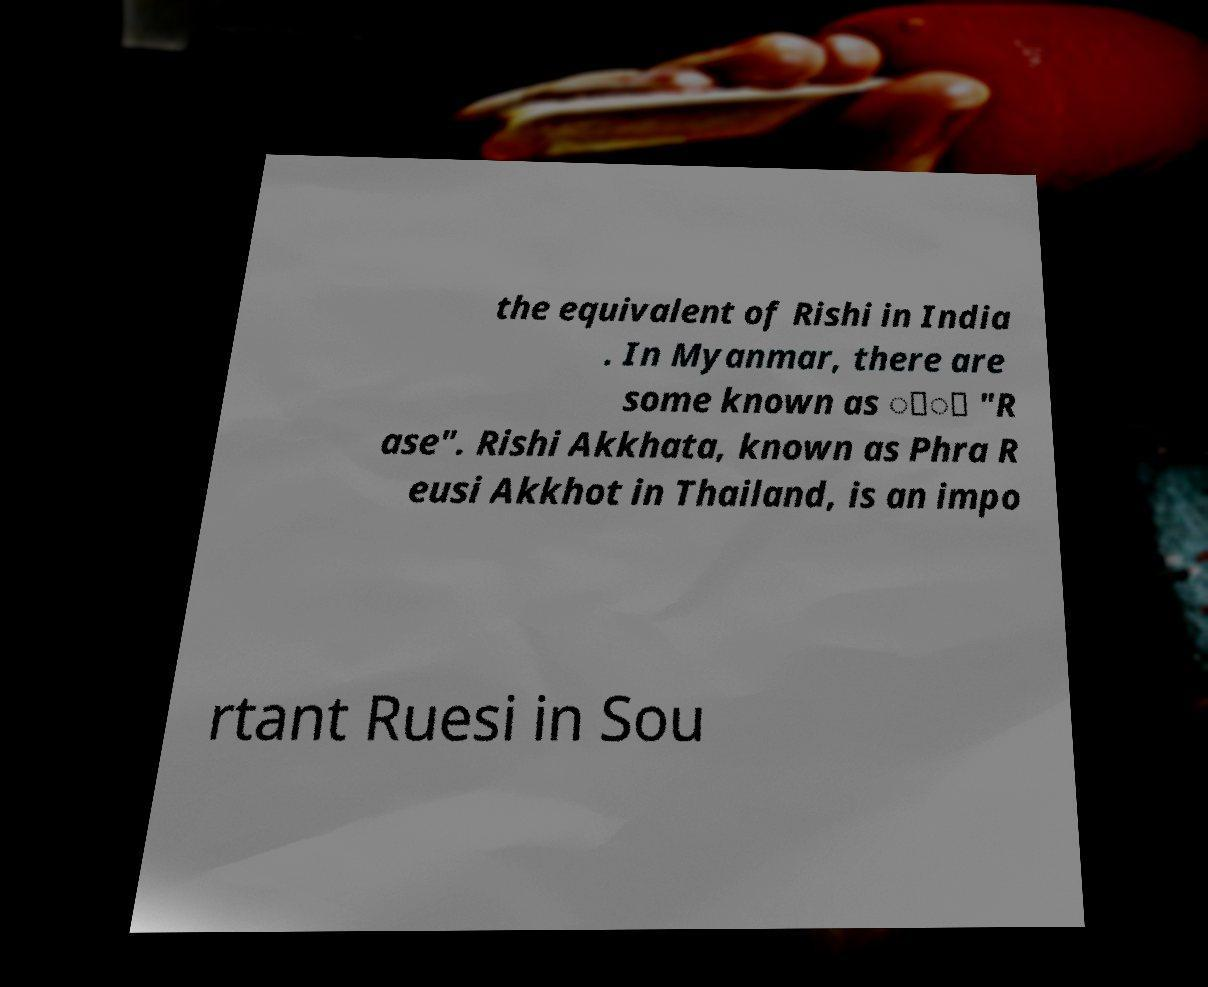What messages or text are displayed in this image? I need them in a readable, typed format. the equivalent of Rishi in India . In Myanmar, there are some known as ေ့ "R ase". Rishi Akkhata, known as Phra R eusi Akkhot in Thailand, is an impo rtant Ruesi in Sou 